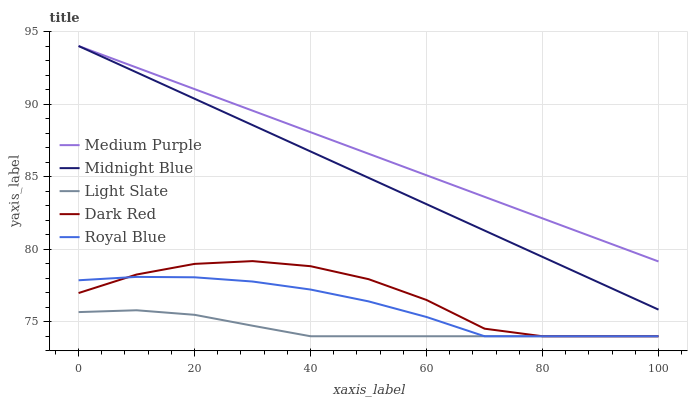Does Light Slate have the minimum area under the curve?
Answer yes or no. Yes. Does Medium Purple have the maximum area under the curve?
Answer yes or no. Yes. Does Midnight Blue have the minimum area under the curve?
Answer yes or no. No. Does Midnight Blue have the maximum area under the curve?
Answer yes or no. No. Is Medium Purple the smoothest?
Answer yes or no. Yes. Is Dark Red the roughest?
Answer yes or no. Yes. Is Light Slate the smoothest?
Answer yes or no. No. Is Light Slate the roughest?
Answer yes or no. No. Does Light Slate have the lowest value?
Answer yes or no. Yes. Does Midnight Blue have the lowest value?
Answer yes or no. No. Does Midnight Blue have the highest value?
Answer yes or no. Yes. Does Light Slate have the highest value?
Answer yes or no. No. Is Light Slate less than Midnight Blue?
Answer yes or no. Yes. Is Medium Purple greater than Light Slate?
Answer yes or no. Yes. Does Dark Red intersect Light Slate?
Answer yes or no. Yes. Is Dark Red less than Light Slate?
Answer yes or no. No. Is Dark Red greater than Light Slate?
Answer yes or no. No. Does Light Slate intersect Midnight Blue?
Answer yes or no. No. 